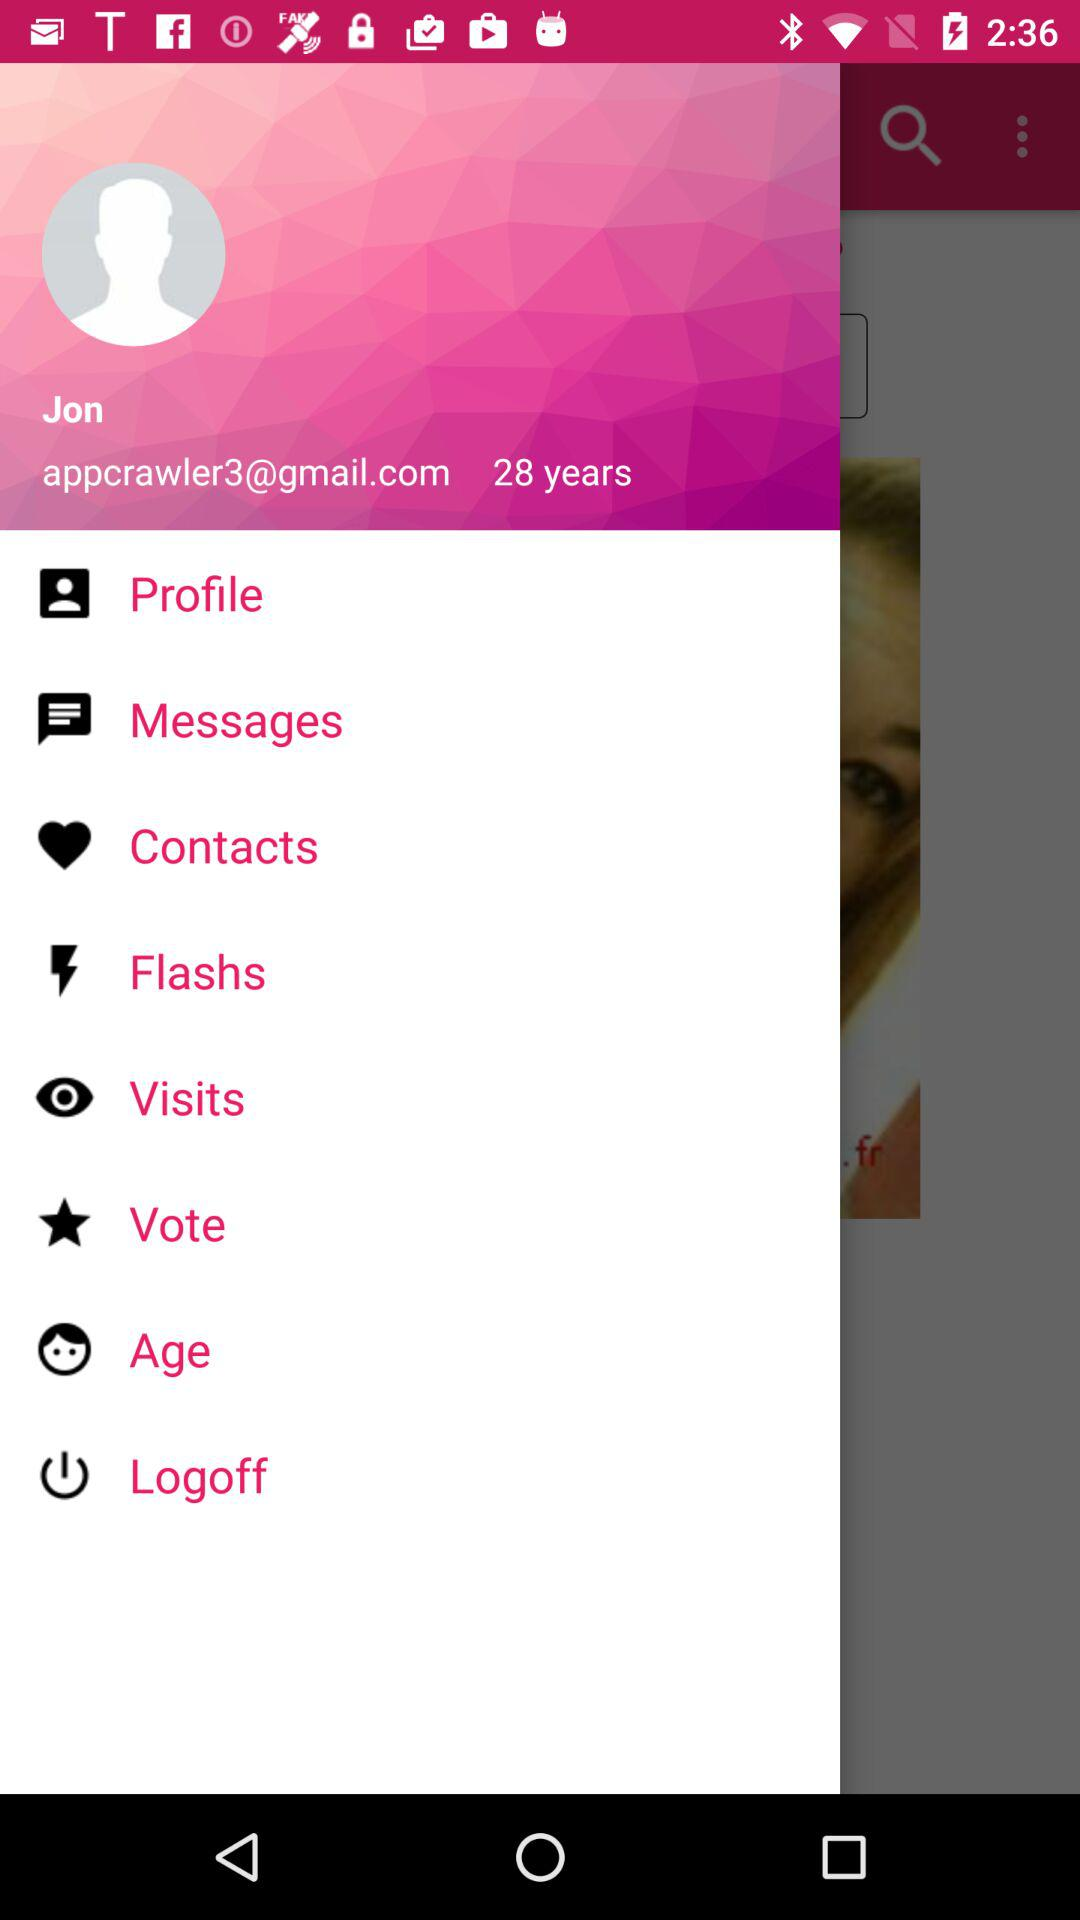What is the email address? The email address is appcrawler3@gmail.com. 